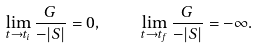<formula> <loc_0><loc_0><loc_500><loc_500>\lim _ { t \rightarrow t _ { i } } \frac { G } { - | S | } = 0 , \quad \lim _ { t \rightarrow t _ { f } } \frac { G } { - | S | } = - \infty .</formula> 